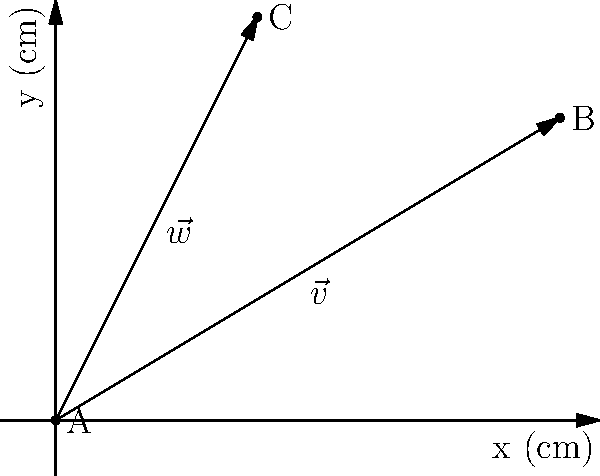In a hydroponic system, nutrient delivery paths are represented by vectors. Given two nutrient delivery vectors $\vec{v} = \langle 5, 3 \rangle$ and $\vec{w} = \langle 2, 4 \rangle$ (measured in cm), calculate the magnitude of the resultant vector $\vec{r} = \vec{v} + \vec{w}$. This will determine the most efficient combined nutrient path. Round your answer to two decimal places. To solve this problem, we'll follow these steps:

1. Add the two vectors $\vec{v}$ and $\vec{w}$ to find $\vec{r}$:
   $\vec{r} = \vec{v} + \vec{w} = \langle 5, 3 \rangle + \langle 2, 4 \rangle = \langle 7, 7 \rangle$

2. Calculate the magnitude of $\vec{r}$ using the Pythagorean theorem:
   $|\vec{r}| = \sqrt{x^2 + y^2}$, where $x$ and $y$ are the components of $\vec{r}$

3. Substitute the values:
   $|\vec{r}| = \sqrt{7^2 + 7^2} = \sqrt{49 + 49} = \sqrt{98}$

4. Simplify and round to two decimal places:
   $|\vec{r}| = \sqrt{98} \approx 9.90$ cm

The magnitude of the resultant vector $\vec{r}$ represents the most efficient combined nutrient delivery path in the hydroponic system.
Answer: 9.90 cm 